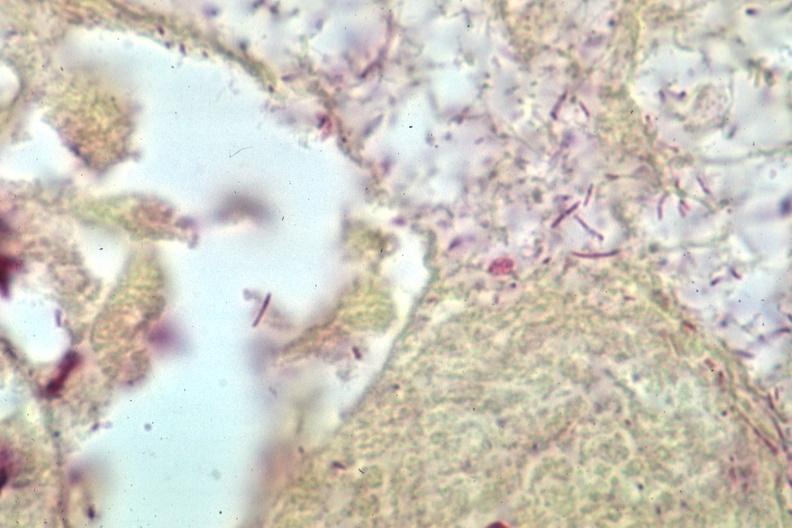s brain present?
Answer the question using a single word or phrase. Yes 